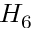Convert formula to latex. <formula><loc_0><loc_0><loc_500><loc_500>H _ { 6 }</formula> 